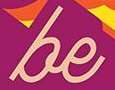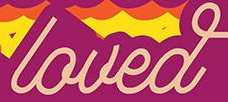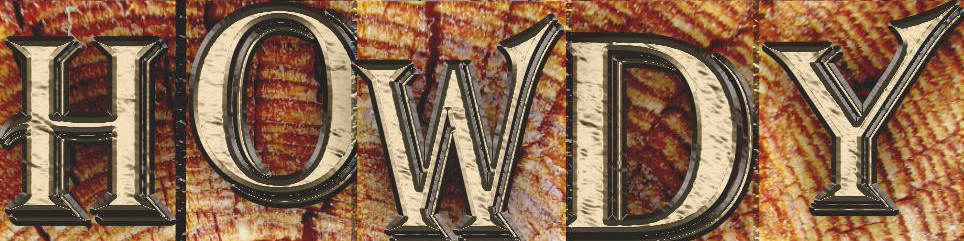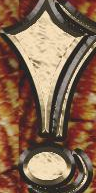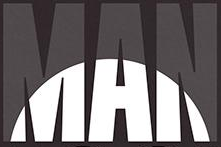Transcribe the words shown in these images in order, separated by a semicolon. be; loved; HOWDY; !; MAN 